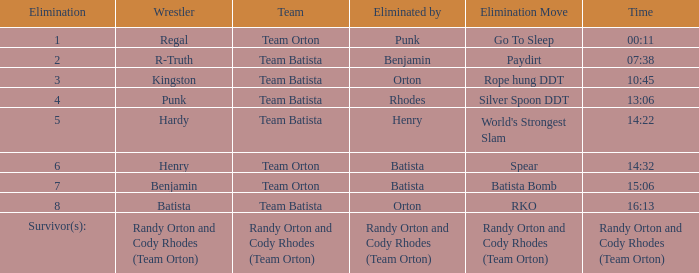What elimination move is noted for wrestler henry, removed by batista? Spear. 